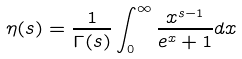<formula> <loc_0><loc_0><loc_500><loc_500>\eta ( s ) = { \frac { 1 } { \Gamma ( s ) } } \int _ { 0 } ^ { \infty } { \frac { x ^ { s - 1 } } { e ^ { x } + 1 } } { d x }</formula> 